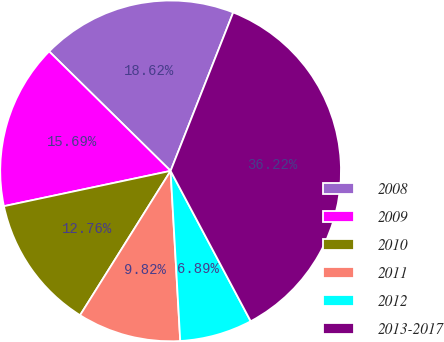<chart> <loc_0><loc_0><loc_500><loc_500><pie_chart><fcel>2008<fcel>2009<fcel>2010<fcel>2011<fcel>2012<fcel>2013-2017<nl><fcel>18.62%<fcel>15.69%<fcel>12.76%<fcel>9.82%<fcel>6.89%<fcel>36.22%<nl></chart> 